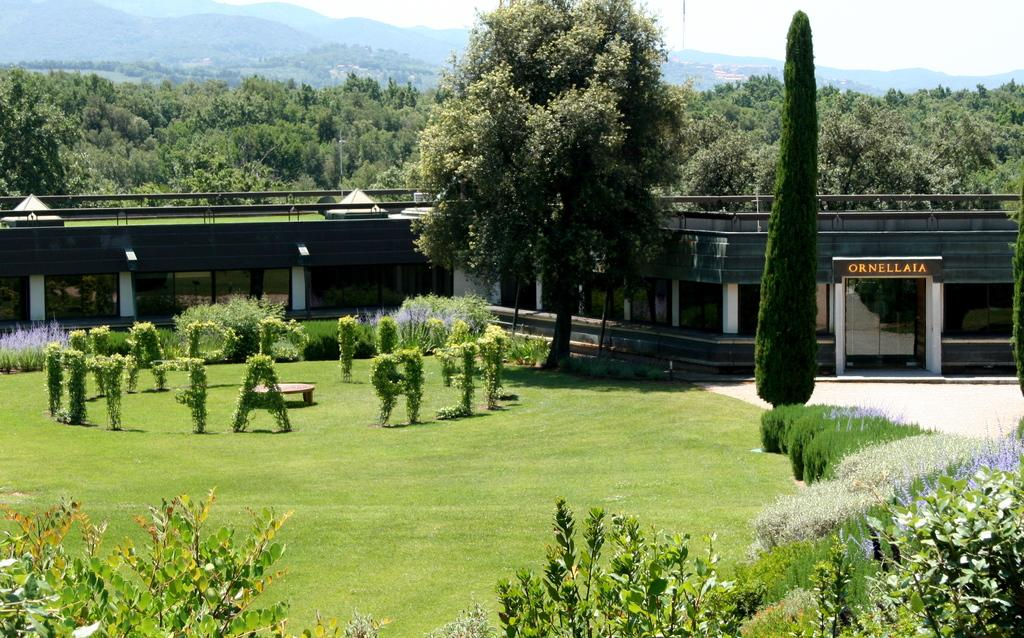What type of structure is visible in the image? There is a building in the image. What else can be seen in the image besides the building? There are plants in the image, cut into a shape, and mountains in the background. What is the condition of the sky in the image? The sky is clear in the image. What type of dress is the stick wearing in the image? There is no stick or dress present in the image. 